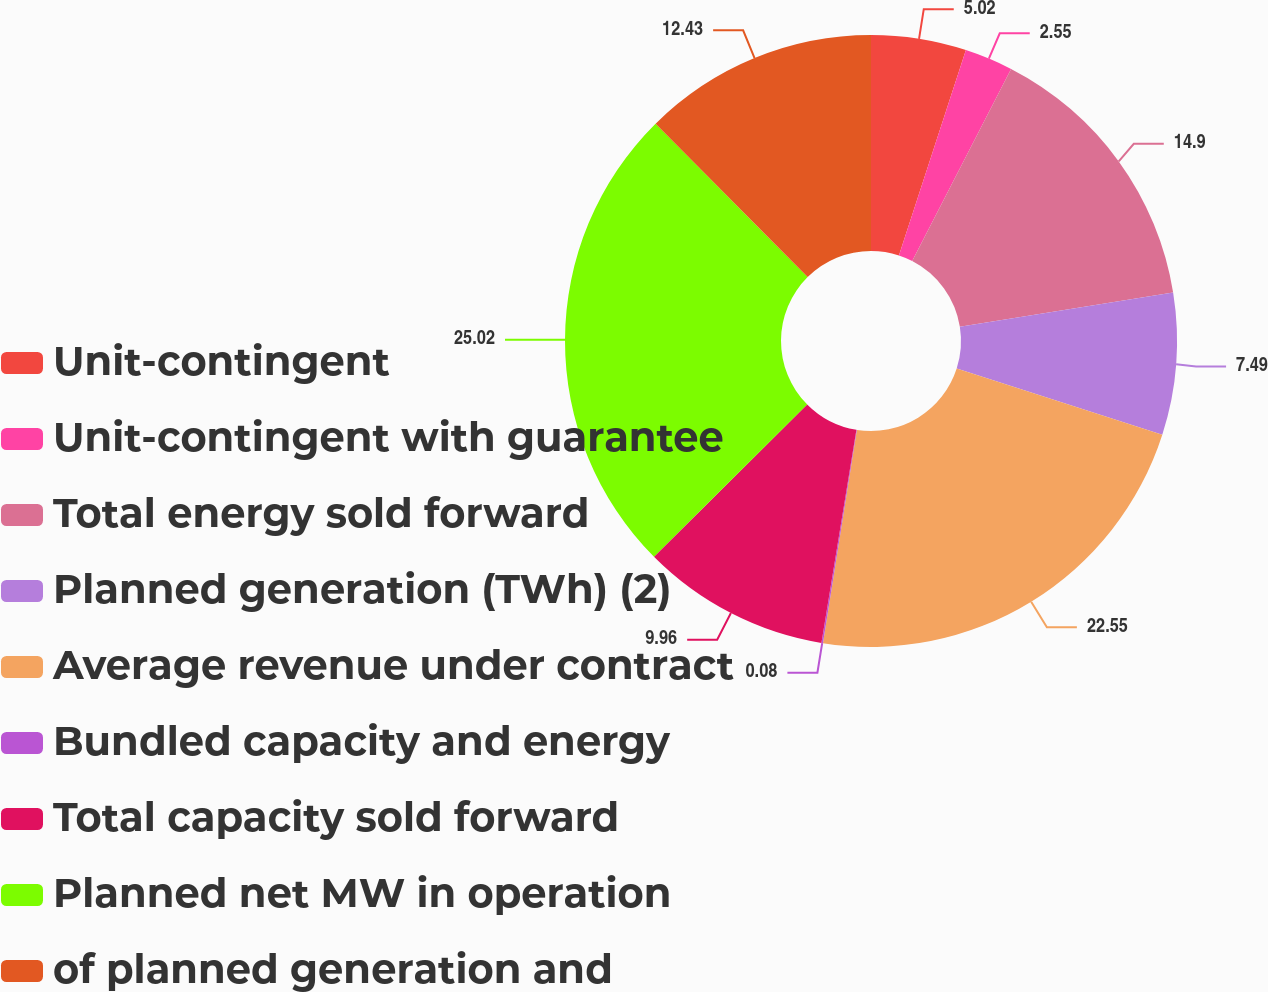Convert chart to OTSL. <chart><loc_0><loc_0><loc_500><loc_500><pie_chart><fcel>Unit-contingent<fcel>Unit-contingent with guarantee<fcel>Total energy sold forward<fcel>Planned generation (TWh) (2)<fcel>Average revenue under contract<fcel>Bundled capacity and energy<fcel>Total capacity sold forward<fcel>Planned net MW in operation<fcel>of planned generation and<nl><fcel>5.02%<fcel>2.55%<fcel>14.9%<fcel>7.49%<fcel>22.56%<fcel>0.08%<fcel>9.96%<fcel>25.03%<fcel>12.43%<nl></chart> 